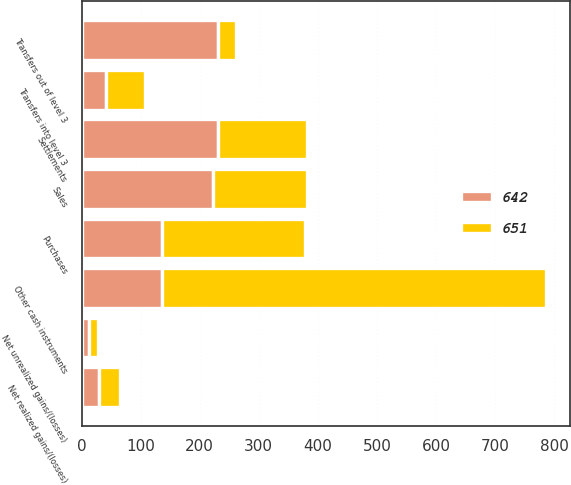Convert chart. <chart><loc_0><loc_0><loc_500><loc_500><stacked_bar_chart><ecel><fcel>Other cash instruments<fcel>Net realized gains/(losses)<fcel>Net unrealized gains/(losses)<fcel>Purchases<fcel>Sales<fcel>Settlements<fcel>Transfers into level 3<fcel>Transfers out of level 3<nl><fcel>651<fcel>651<fcel>35<fcel>15<fcel>243<fcel>158<fcel>151<fcel>67<fcel>30<nl><fcel>642<fcel>136<fcel>30<fcel>13<fcel>136<fcel>223<fcel>231<fcel>41<fcel>231<nl></chart> 